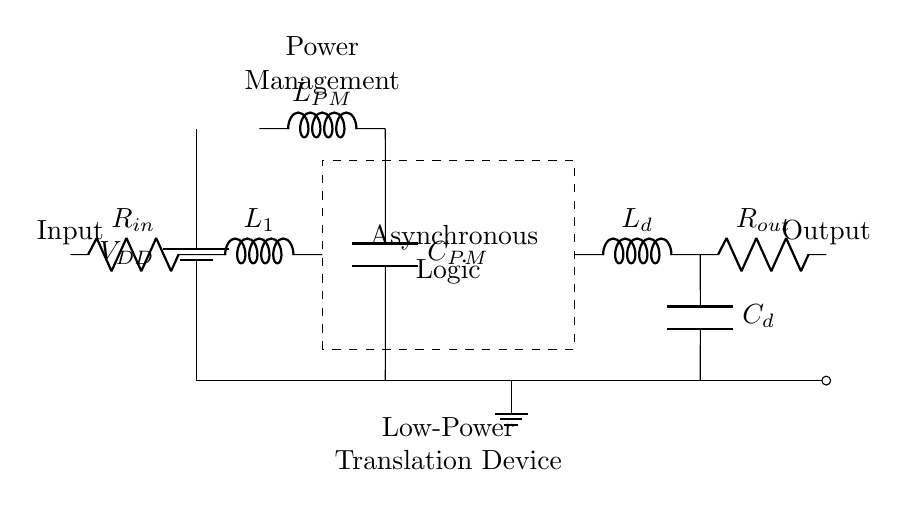What is the function of the battery in this circuit? The battery provides the power supply, denoted as VDD, which serves as the voltage source for the circuit.
Answer: Power supply What is the role of the inductor labeled L1? The inductor L1 is part of the input stage, acting as a filtering or smoothing component to manage the input signal.
Answer: Input filtering What does the dashed rectangle represent? The dashed rectangle encloses the asynchronous logic block, which processes the input signals without relying on a global clock signal.
Answer: Asynchronous logic How many components are connected in series after the delay element? There are two components (inductor Ld and capacitor Cd) connected in series after the delay element leading to the output stage.
Answer: Two What is the purpose of the power management section? The power management section, with components labeled LPM and CPM, ensures efficient power handling and regulation for the entire circuit.
Answer: Power regulation What type of circuit does the label "Low-Power Translation Device" indicate? The label suggests that the circuit is designed specifically as a translation device, indicating its purpose in communication or language translation applications.
Answer: Translation device What is the significance of using an asynchronous circuit here? The use of an asynchronous circuit facilitates low-power operation and avoids clock-induced delays, making it suitable for portable applications.
Answer: Low-power operation 